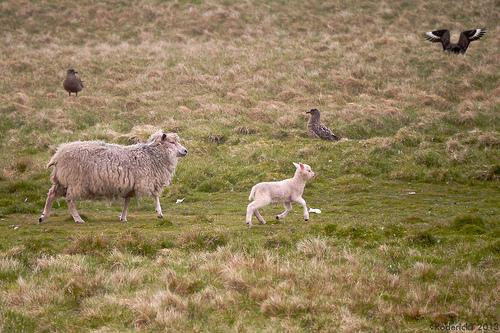Question: where is the sheep standing?
Choices:
A. Fenced-in area.
B. A platform.
C. A mountain.
D. Field.
Answer with the letter. Answer: D Question: who is flying?
Choices:
A. A man.
B. An eagle.
C. A bird.
D. A cardinal.
Answer with the letter. Answer: C Question: how many birds?
Choices:
A. Four.
B. Five.
C. Seven.
D. Three.
Answer with the letter. Answer: D Question: what is on the ground?
Choices:
A. Gravel.
B. Wildflowers.
C. Grass.
D. Mud.
Answer with the letter. Answer: C 